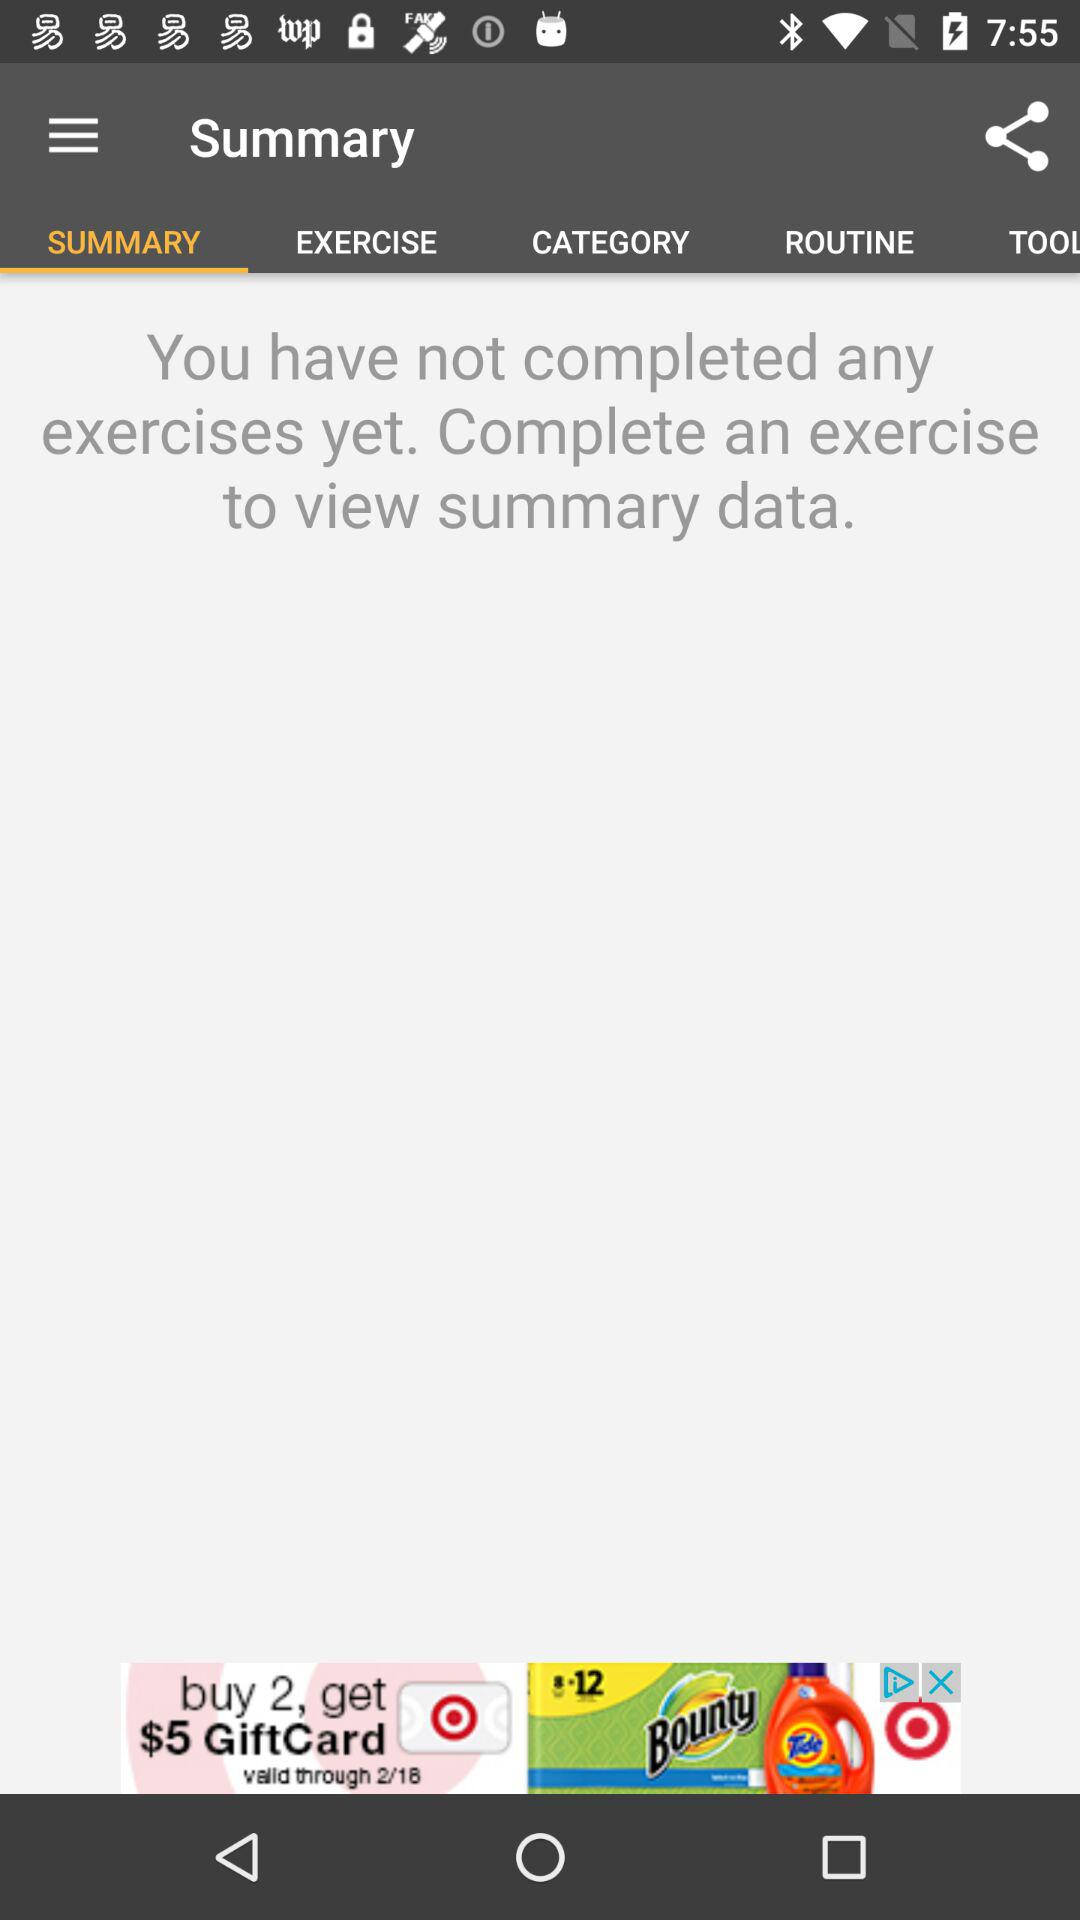Which tab is selected? The selected tab is "SUMMARY". 